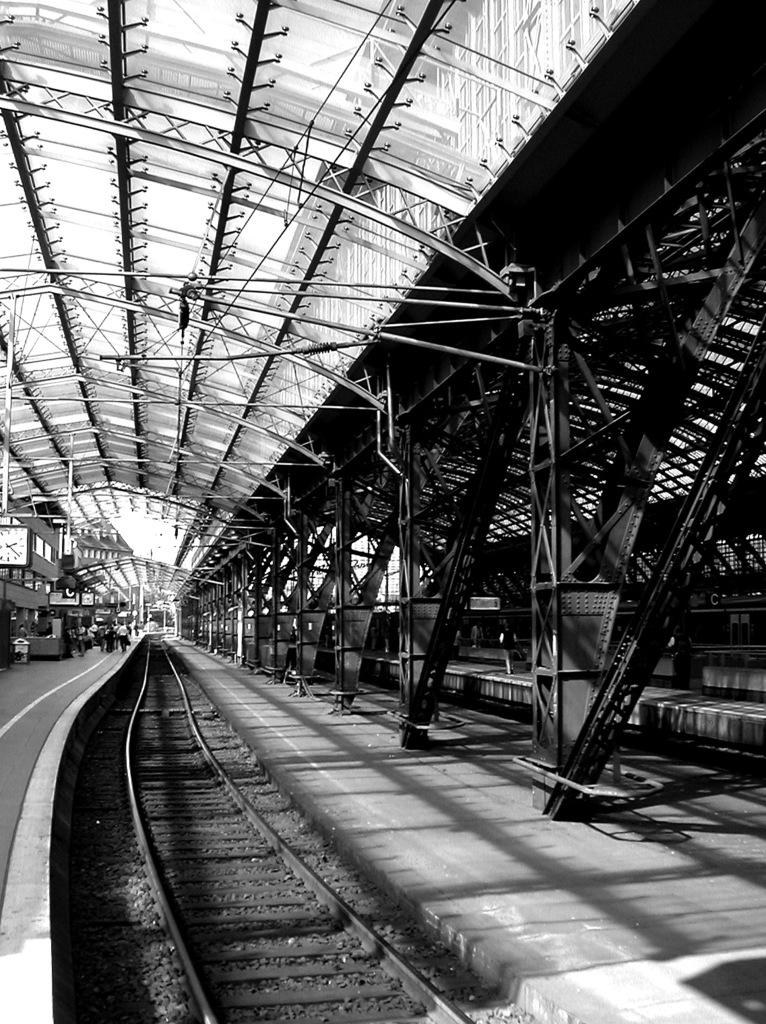What can be seen running through the image? There is a railway track in the image. Where are the people located in the image? The people are on a platform in the image. What time-related object is present in the image? There is a clock in the image. What can be seen in the background of the image? There are rods visible in the background of the image. Can you tell me how many basketballs are visible on the railway track in the image? There are no basketballs present on the railway track in the image. 